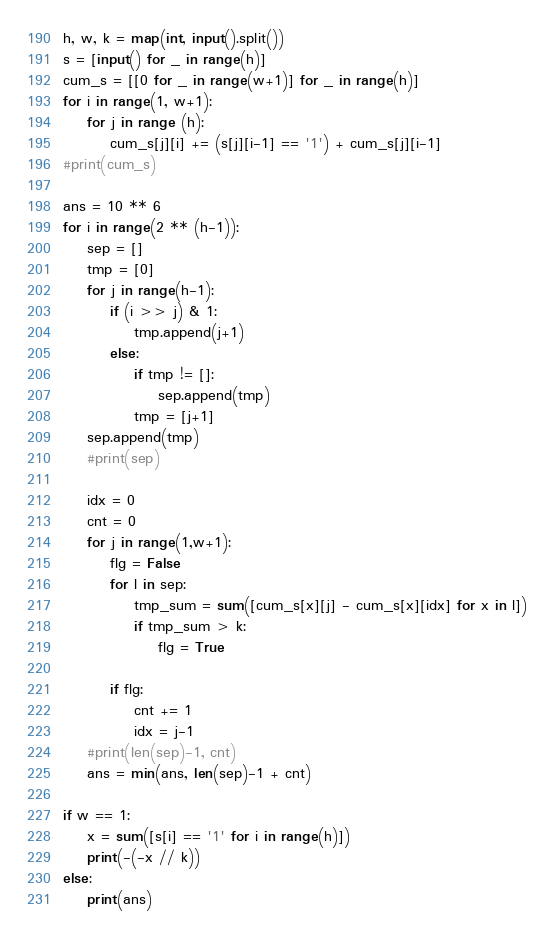<code> <loc_0><loc_0><loc_500><loc_500><_Python_>h, w, k = map(int, input().split())
s = [input() for _ in range(h)]
cum_s = [[0 for _ in range(w+1)] for _ in range(h)]
for i in range(1, w+1):
    for j in range (h):
        cum_s[j][i] += (s[j][i-1] == '1') + cum_s[j][i-1]
#print(cum_s)

ans = 10 ** 6
for i in range(2 ** (h-1)):
    sep = []
    tmp = [0]
    for j in range(h-1):
        if (i >> j) & 1:
            tmp.append(j+1)
        else:
            if tmp != []:
                sep.append(tmp)
            tmp = [j+1]
    sep.append(tmp)
    #print(sep)
    
    idx = 0
    cnt = 0
    for j in range(1,w+1):
        flg = False
        for l in sep:
            tmp_sum = sum([cum_s[x][j] - cum_s[x][idx] for x in l])
            if tmp_sum > k:
                flg = True
        
        if flg:
            cnt += 1
            idx = j-1 
    #print(len(sep)-1, cnt)
    ans = min(ans, len(sep)-1 + cnt)

if w == 1:
    x = sum([s[i] == '1' for i in range(h)])
    print(-(-x // k))
else:
    print(ans)</code> 